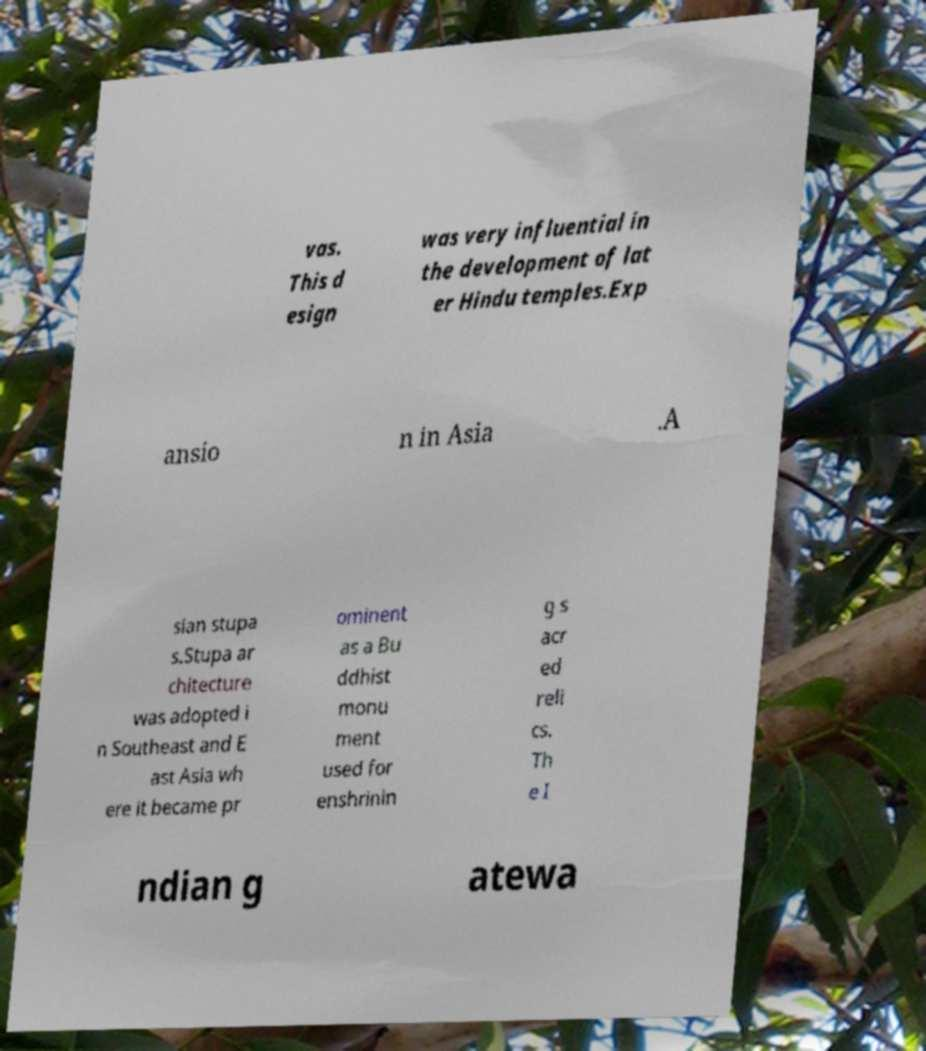Could you assist in decoding the text presented in this image and type it out clearly? vas. This d esign was very influential in the development of lat er Hindu temples.Exp ansio n in Asia .A sian stupa s.Stupa ar chitecture was adopted i n Southeast and E ast Asia wh ere it became pr ominent as a Bu ddhist monu ment used for enshrinin g s acr ed reli cs. Th e I ndian g atewa 